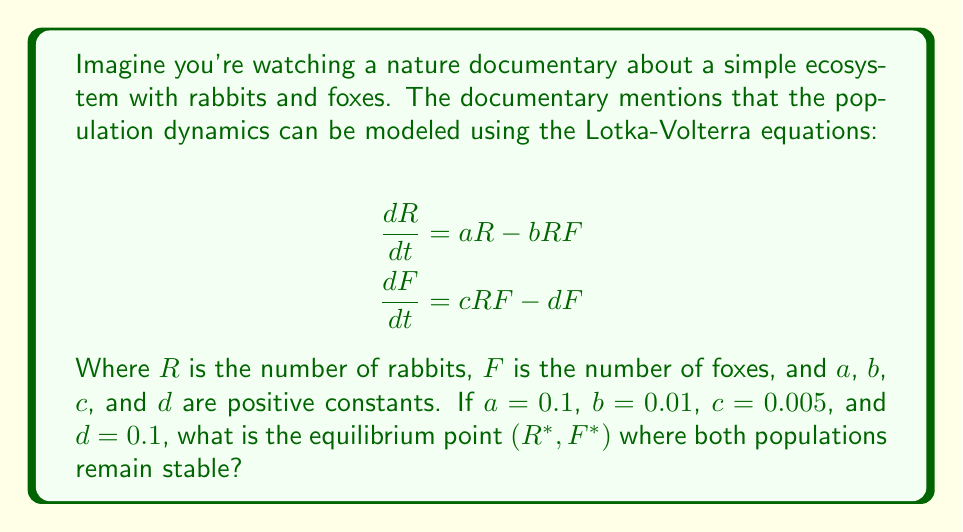Give your solution to this math problem. Let's approach this step-by-step:

1) At equilibrium, the rate of change for both populations is zero. So we set both equations to zero:

   $$\frac{dR}{dt} = aR - bRF = 0$$
   $$\frac{dF}{dt} = cRF - dF = 0$$

2) From the second equation:
   $$cRF - dF = 0$$
   $$F(cR - d) = 0$$

   This is true when $F = 0$ or when $cR - d = 0$. Since we're looking for a non-zero equilibrium, we'll use:
   $$cR - d = 0$$
   $$cR = d$$
   $$R* = \frac{d}{c} = \frac{0.1}{0.005} = 20$$

3) Now we can use this value of R* in the first equation:
   $$aR - bRF = 0$$
   $$a - bF = 0$$
   $$F* = \frac{a}{b} = \frac{0.1}{0.01} = 10$$

4) Therefore, the equilibrium point (R*, F*) is (20, 10).

This means that when there are 20 rabbits and 10 foxes, the ecosystem is in balance, similar to how a balanced team composition in esports can lead to a stable game state.
Answer: (20, 10) 